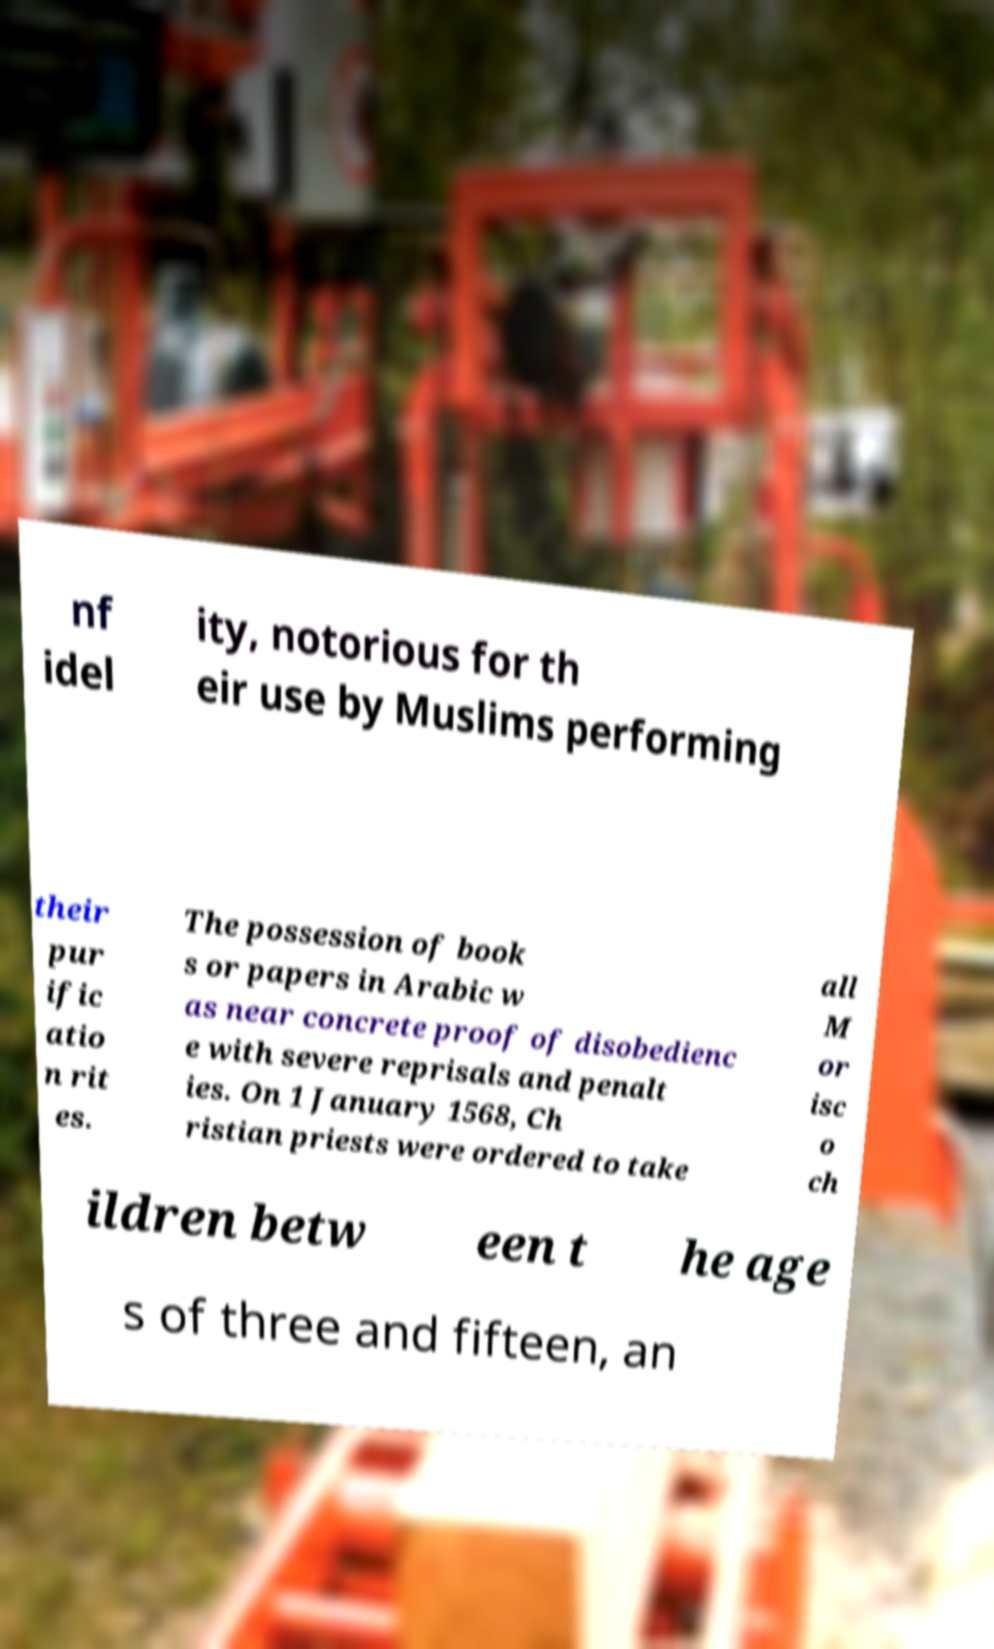Can you accurately transcribe the text from the provided image for me? nf idel ity, notorious for th eir use by Muslims performing their pur ific atio n rit es. The possession of book s or papers in Arabic w as near concrete proof of disobedienc e with severe reprisals and penalt ies. On 1 January 1568, Ch ristian priests were ordered to take all M or isc o ch ildren betw een t he age s of three and fifteen, an 